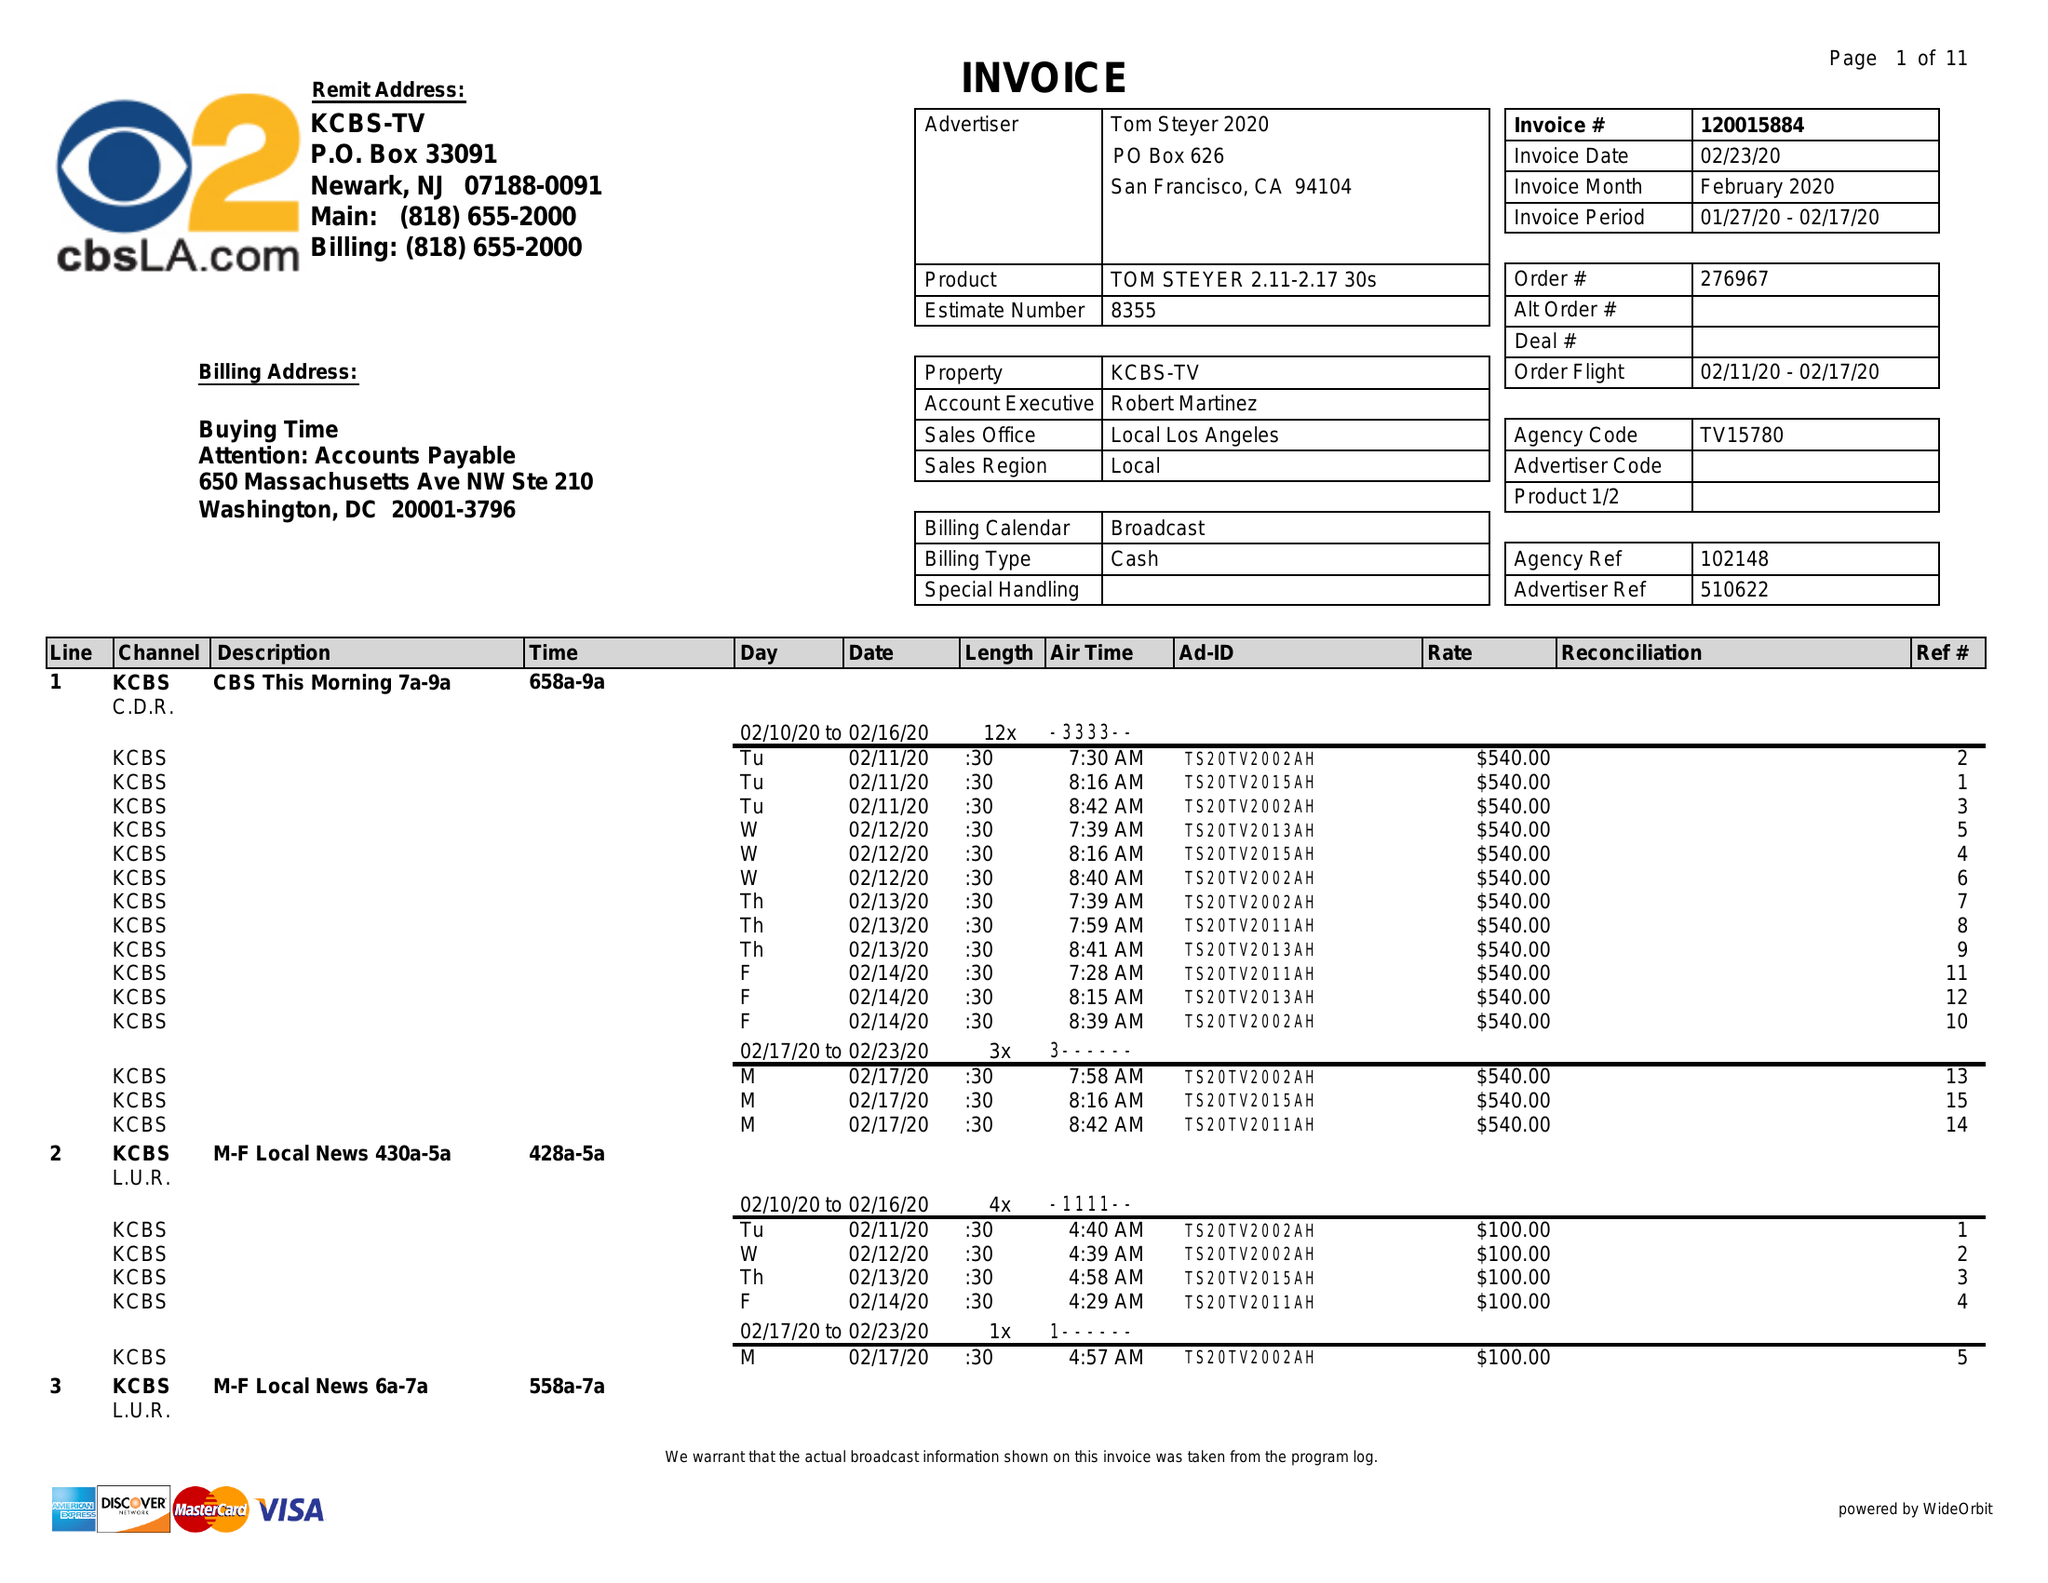What is the value for the contract_num?
Answer the question using a single word or phrase. 120015884 